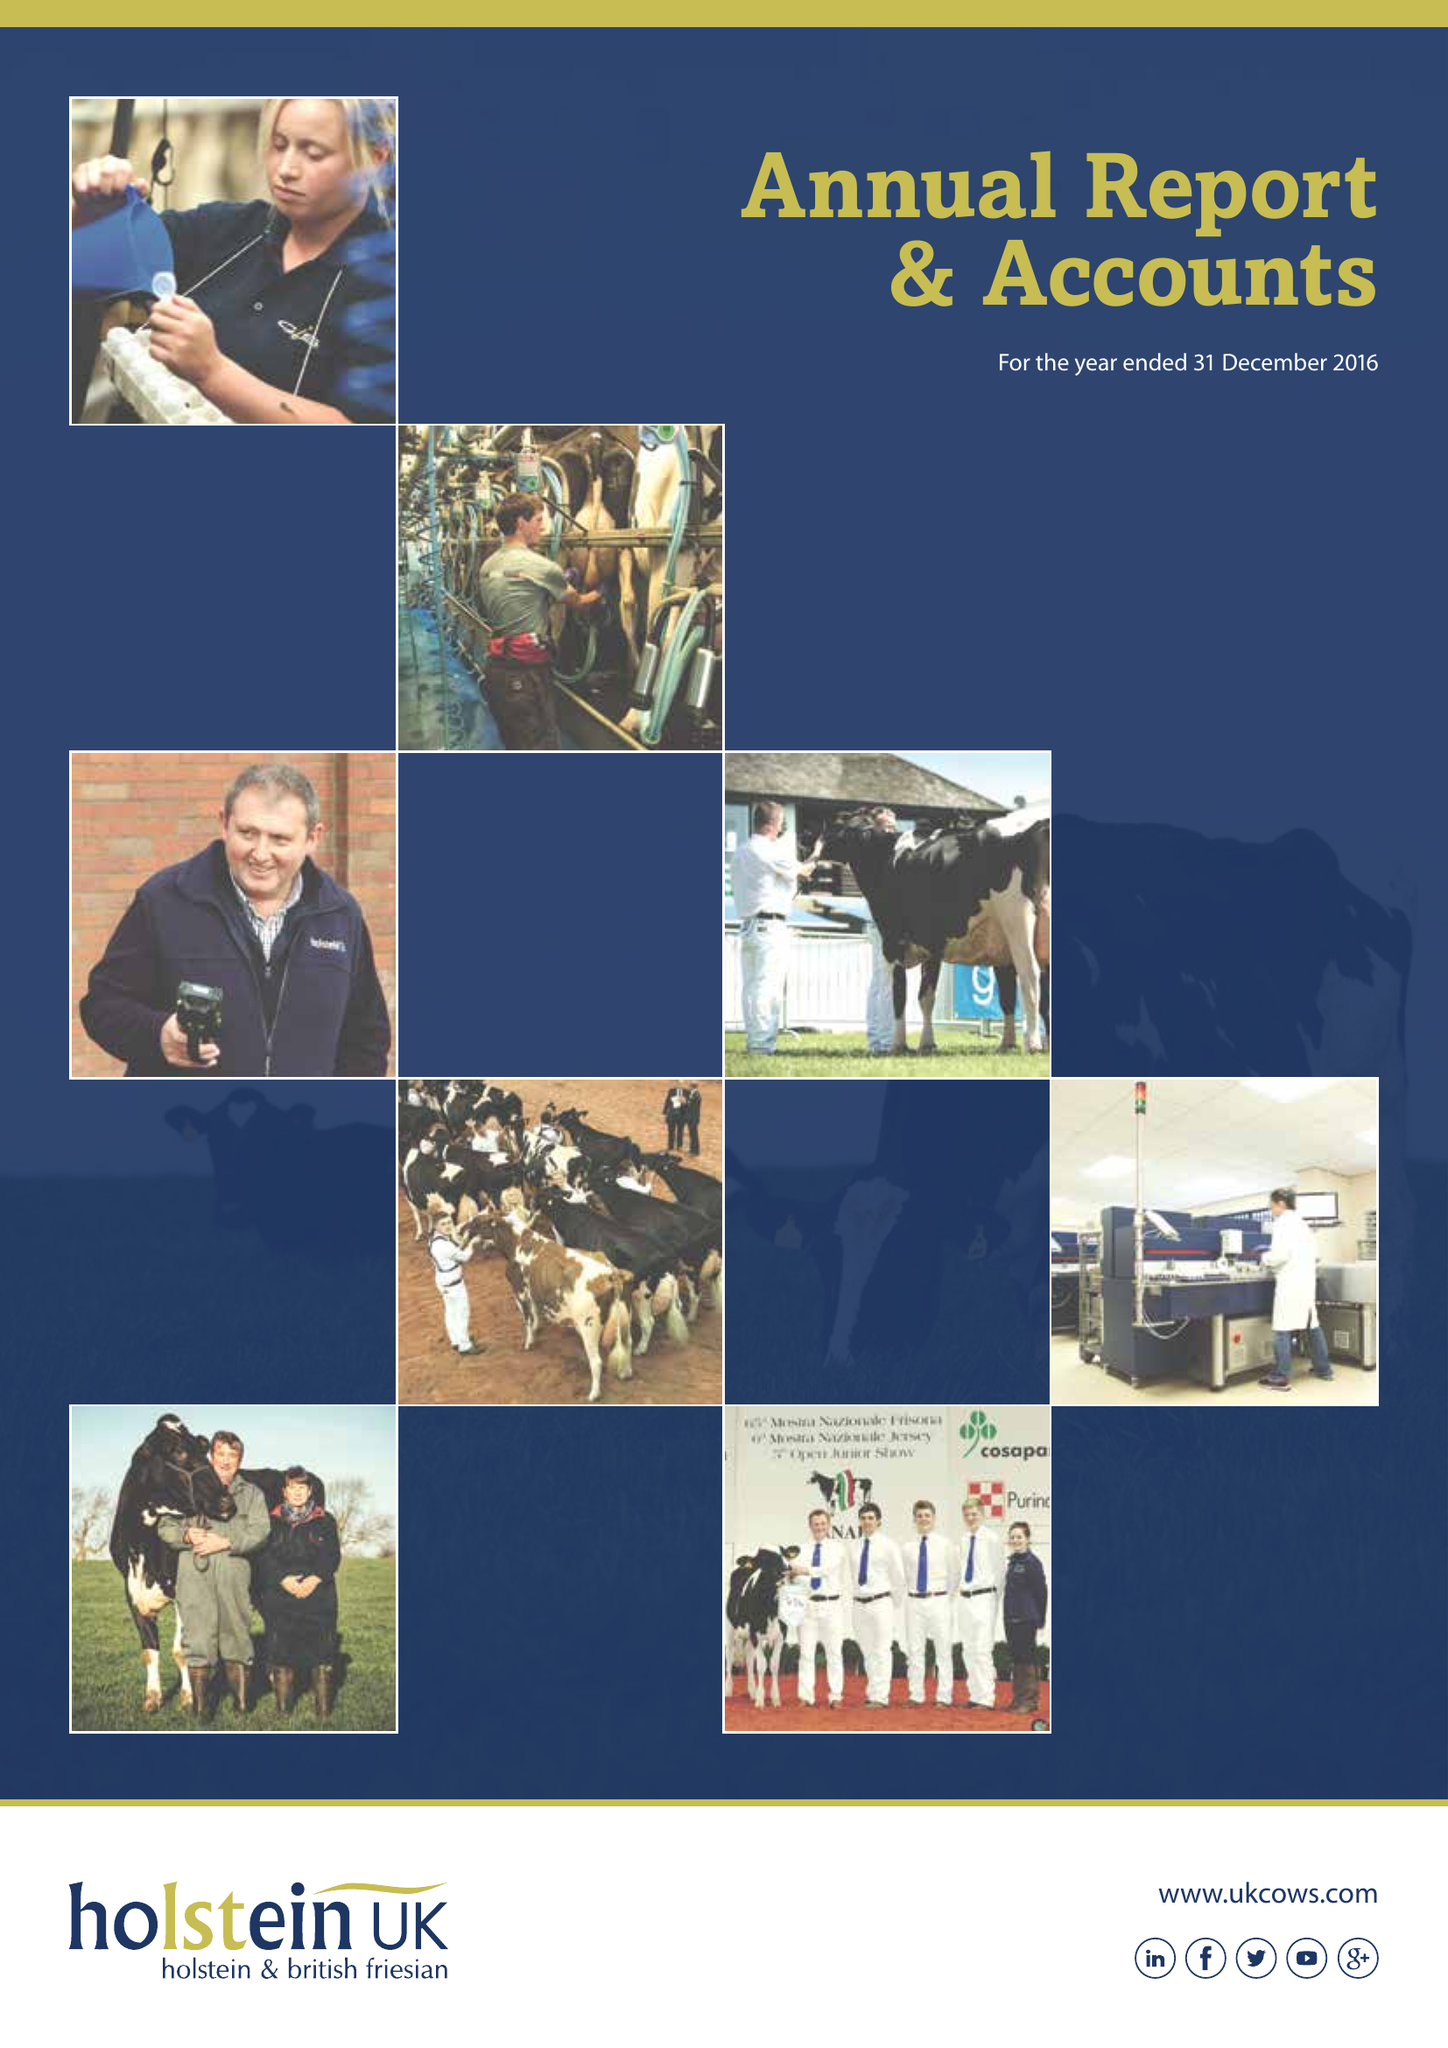What is the value for the address__post_town?
Answer the question using a single word or phrase. TELFORD 